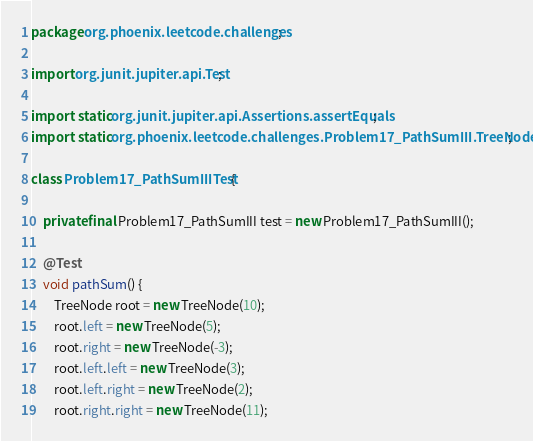Convert code to text. <code><loc_0><loc_0><loc_500><loc_500><_Java_>package org.phoenix.leetcode.challenges;

import org.junit.jupiter.api.Test;

import static org.junit.jupiter.api.Assertions.assertEquals;
import static org.phoenix.leetcode.challenges.Problem17_PathSumIII.TreeNode;

class Problem17_PathSumIIITest {

    private final Problem17_PathSumIII test = new Problem17_PathSumIII();

    @Test
    void pathSum() {
        TreeNode root = new TreeNode(10);
        root.left = new TreeNode(5);
        root.right = new TreeNode(-3);
        root.left.left = new TreeNode(3);
        root.left.right = new TreeNode(2);
        root.right.right = new TreeNode(11);</code> 